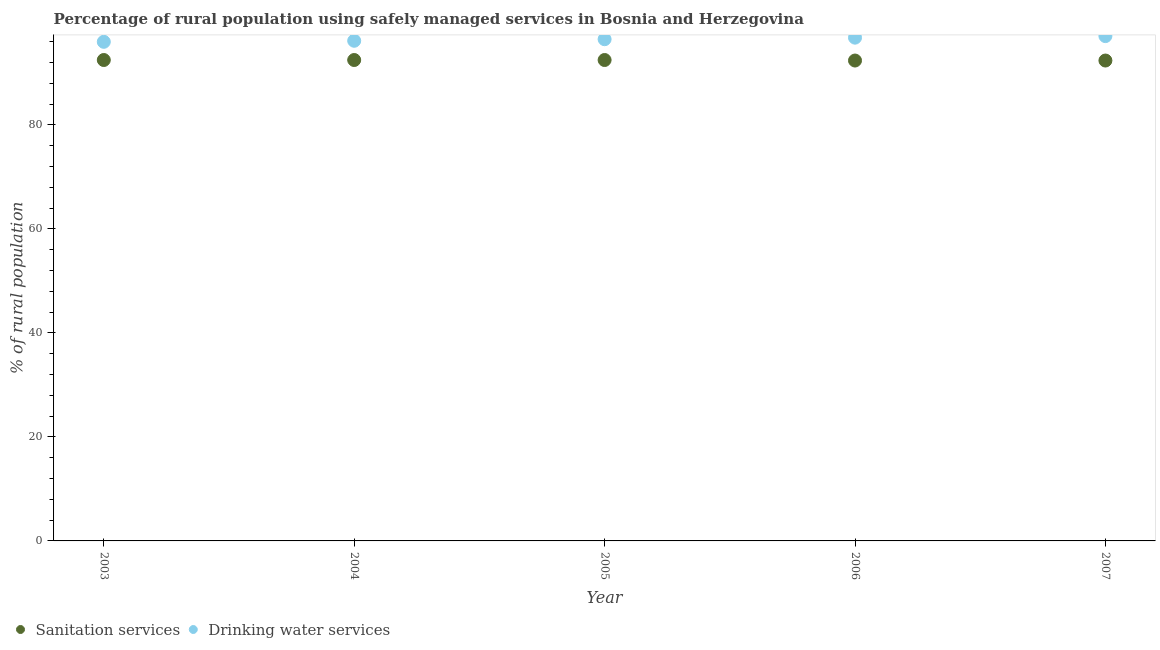How many different coloured dotlines are there?
Your answer should be compact. 2. Is the number of dotlines equal to the number of legend labels?
Keep it short and to the point. Yes. What is the percentage of rural population who used drinking water services in 2007?
Offer a terse response. 97.1. Across all years, what is the maximum percentage of rural population who used drinking water services?
Keep it short and to the point. 97.1. Across all years, what is the minimum percentage of rural population who used drinking water services?
Give a very brief answer. 96. What is the total percentage of rural population who used sanitation services in the graph?
Ensure brevity in your answer.  462.3. What is the difference between the percentage of rural population who used sanitation services in 2005 and that in 2007?
Offer a terse response. 0.1. What is the difference between the percentage of rural population who used drinking water services in 2007 and the percentage of rural population who used sanitation services in 2004?
Give a very brief answer. 4.6. What is the average percentage of rural population who used drinking water services per year?
Keep it short and to the point. 96.52. In the year 2006, what is the difference between the percentage of rural population who used drinking water services and percentage of rural population who used sanitation services?
Keep it short and to the point. 4.4. What is the difference between the highest and the lowest percentage of rural population who used sanitation services?
Ensure brevity in your answer.  0.1. In how many years, is the percentage of rural population who used sanitation services greater than the average percentage of rural population who used sanitation services taken over all years?
Your response must be concise. 3. Does the percentage of rural population who used drinking water services monotonically increase over the years?
Offer a terse response. Yes. Is the percentage of rural population who used sanitation services strictly less than the percentage of rural population who used drinking water services over the years?
Give a very brief answer. Yes. How many dotlines are there?
Offer a very short reply. 2. Where does the legend appear in the graph?
Your response must be concise. Bottom left. What is the title of the graph?
Ensure brevity in your answer.  Percentage of rural population using safely managed services in Bosnia and Herzegovina. What is the label or title of the Y-axis?
Offer a terse response. % of rural population. What is the % of rural population in Sanitation services in 2003?
Keep it short and to the point. 92.5. What is the % of rural population of Drinking water services in 2003?
Your answer should be compact. 96. What is the % of rural population of Sanitation services in 2004?
Make the answer very short. 92.5. What is the % of rural population of Drinking water services in 2004?
Provide a short and direct response. 96.2. What is the % of rural population of Sanitation services in 2005?
Keep it short and to the point. 92.5. What is the % of rural population of Drinking water services in 2005?
Offer a very short reply. 96.5. What is the % of rural population in Sanitation services in 2006?
Make the answer very short. 92.4. What is the % of rural population of Drinking water services in 2006?
Offer a terse response. 96.8. What is the % of rural population of Sanitation services in 2007?
Offer a terse response. 92.4. What is the % of rural population in Drinking water services in 2007?
Your response must be concise. 97.1. Across all years, what is the maximum % of rural population of Sanitation services?
Ensure brevity in your answer.  92.5. Across all years, what is the maximum % of rural population in Drinking water services?
Your answer should be compact. 97.1. Across all years, what is the minimum % of rural population in Sanitation services?
Offer a terse response. 92.4. Across all years, what is the minimum % of rural population in Drinking water services?
Provide a succinct answer. 96. What is the total % of rural population in Sanitation services in the graph?
Provide a succinct answer. 462.3. What is the total % of rural population in Drinking water services in the graph?
Make the answer very short. 482.6. What is the difference between the % of rural population of Sanitation services in 2003 and that in 2004?
Your answer should be very brief. 0. What is the difference between the % of rural population in Drinking water services in 2003 and that in 2004?
Offer a terse response. -0.2. What is the difference between the % of rural population of Drinking water services in 2003 and that in 2005?
Offer a terse response. -0.5. What is the difference between the % of rural population of Sanitation services in 2004 and that in 2005?
Ensure brevity in your answer.  0. What is the difference between the % of rural population in Drinking water services in 2004 and that in 2006?
Your answer should be very brief. -0.6. What is the difference between the % of rural population in Sanitation services in 2004 and that in 2007?
Your response must be concise. 0.1. What is the difference between the % of rural population of Sanitation services in 2005 and that in 2007?
Provide a short and direct response. 0.1. What is the difference between the % of rural population in Sanitation services in 2006 and that in 2007?
Your answer should be very brief. 0. What is the difference between the % of rural population of Sanitation services in 2003 and the % of rural population of Drinking water services in 2004?
Your response must be concise. -3.7. What is the difference between the % of rural population in Sanitation services in 2003 and the % of rural population in Drinking water services in 2005?
Provide a short and direct response. -4. What is the difference between the % of rural population of Sanitation services in 2003 and the % of rural population of Drinking water services in 2006?
Provide a succinct answer. -4.3. What is the difference between the % of rural population of Sanitation services in 2003 and the % of rural population of Drinking water services in 2007?
Offer a very short reply. -4.6. What is the difference between the % of rural population in Sanitation services in 2004 and the % of rural population in Drinking water services in 2006?
Keep it short and to the point. -4.3. What is the difference between the % of rural population in Sanitation services in 2004 and the % of rural population in Drinking water services in 2007?
Your answer should be very brief. -4.6. What is the difference between the % of rural population in Sanitation services in 2006 and the % of rural population in Drinking water services in 2007?
Provide a succinct answer. -4.7. What is the average % of rural population in Sanitation services per year?
Keep it short and to the point. 92.46. What is the average % of rural population in Drinking water services per year?
Give a very brief answer. 96.52. In the year 2003, what is the difference between the % of rural population of Sanitation services and % of rural population of Drinking water services?
Your response must be concise. -3.5. In the year 2004, what is the difference between the % of rural population of Sanitation services and % of rural population of Drinking water services?
Offer a very short reply. -3.7. In the year 2005, what is the difference between the % of rural population in Sanitation services and % of rural population in Drinking water services?
Ensure brevity in your answer.  -4. In the year 2006, what is the difference between the % of rural population in Sanitation services and % of rural population in Drinking water services?
Keep it short and to the point. -4.4. In the year 2007, what is the difference between the % of rural population of Sanitation services and % of rural population of Drinking water services?
Ensure brevity in your answer.  -4.7. What is the ratio of the % of rural population in Sanitation services in 2003 to that in 2005?
Give a very brief answer. 1. What is the ratio of the % of rural population of Sanitation services in 2003 to that in 2006?
Keep it short and to the point. 1. What is the ratio of the % of rural population in Drinking water services in 2003 to that in 2006?
Ensure brevity in your answer.  0.99. What is the ratio of the % of rural population in Sanitation services in 2003 to that in 2007?
Provide a short and direct response. 1. What is the ratio of the % of rural population in Drinking water services in 2003 to that in 2007?
Provide a succinct answer. 0.99. What is the ratio of the % of rural population in Sanitation services in 2004 to that in 2005?
Ensure brevity in your answer.  1. What is the ratio of the % of rural population of Sanitation services in 2005 to that in 2007?
Your answer should be very brief. 1. What is the difference between the highest and the second highest % of rural population of Sanitation services?
Your answer should be very brief. 0. What is the difference between the highest and the second highest % of rural population in Drinking water services?
Offer a terse response. 0.3. What is the difference between the highest and the lowest % of rural population in Drinking water services?
Offer a terse response. 1.1. 